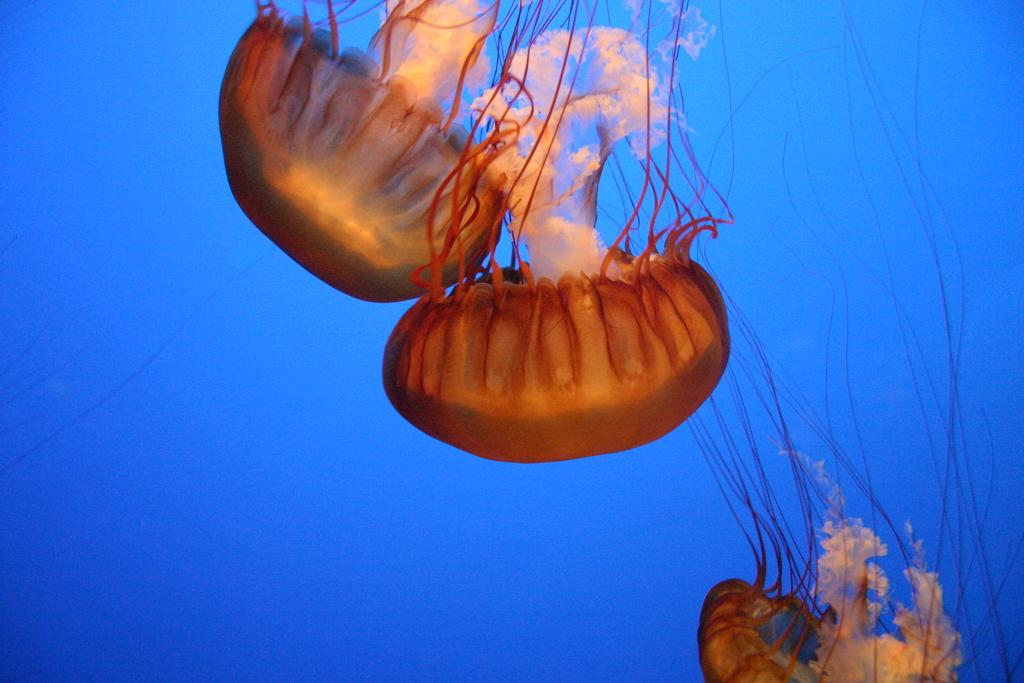What type of animals can be seen in the water in the image? There are jellyfishes in the water in the image. What type of toad can be seen sitting on the vase in the image? There is no toad or vase present in the image; it only features jellyfishes in the water. 